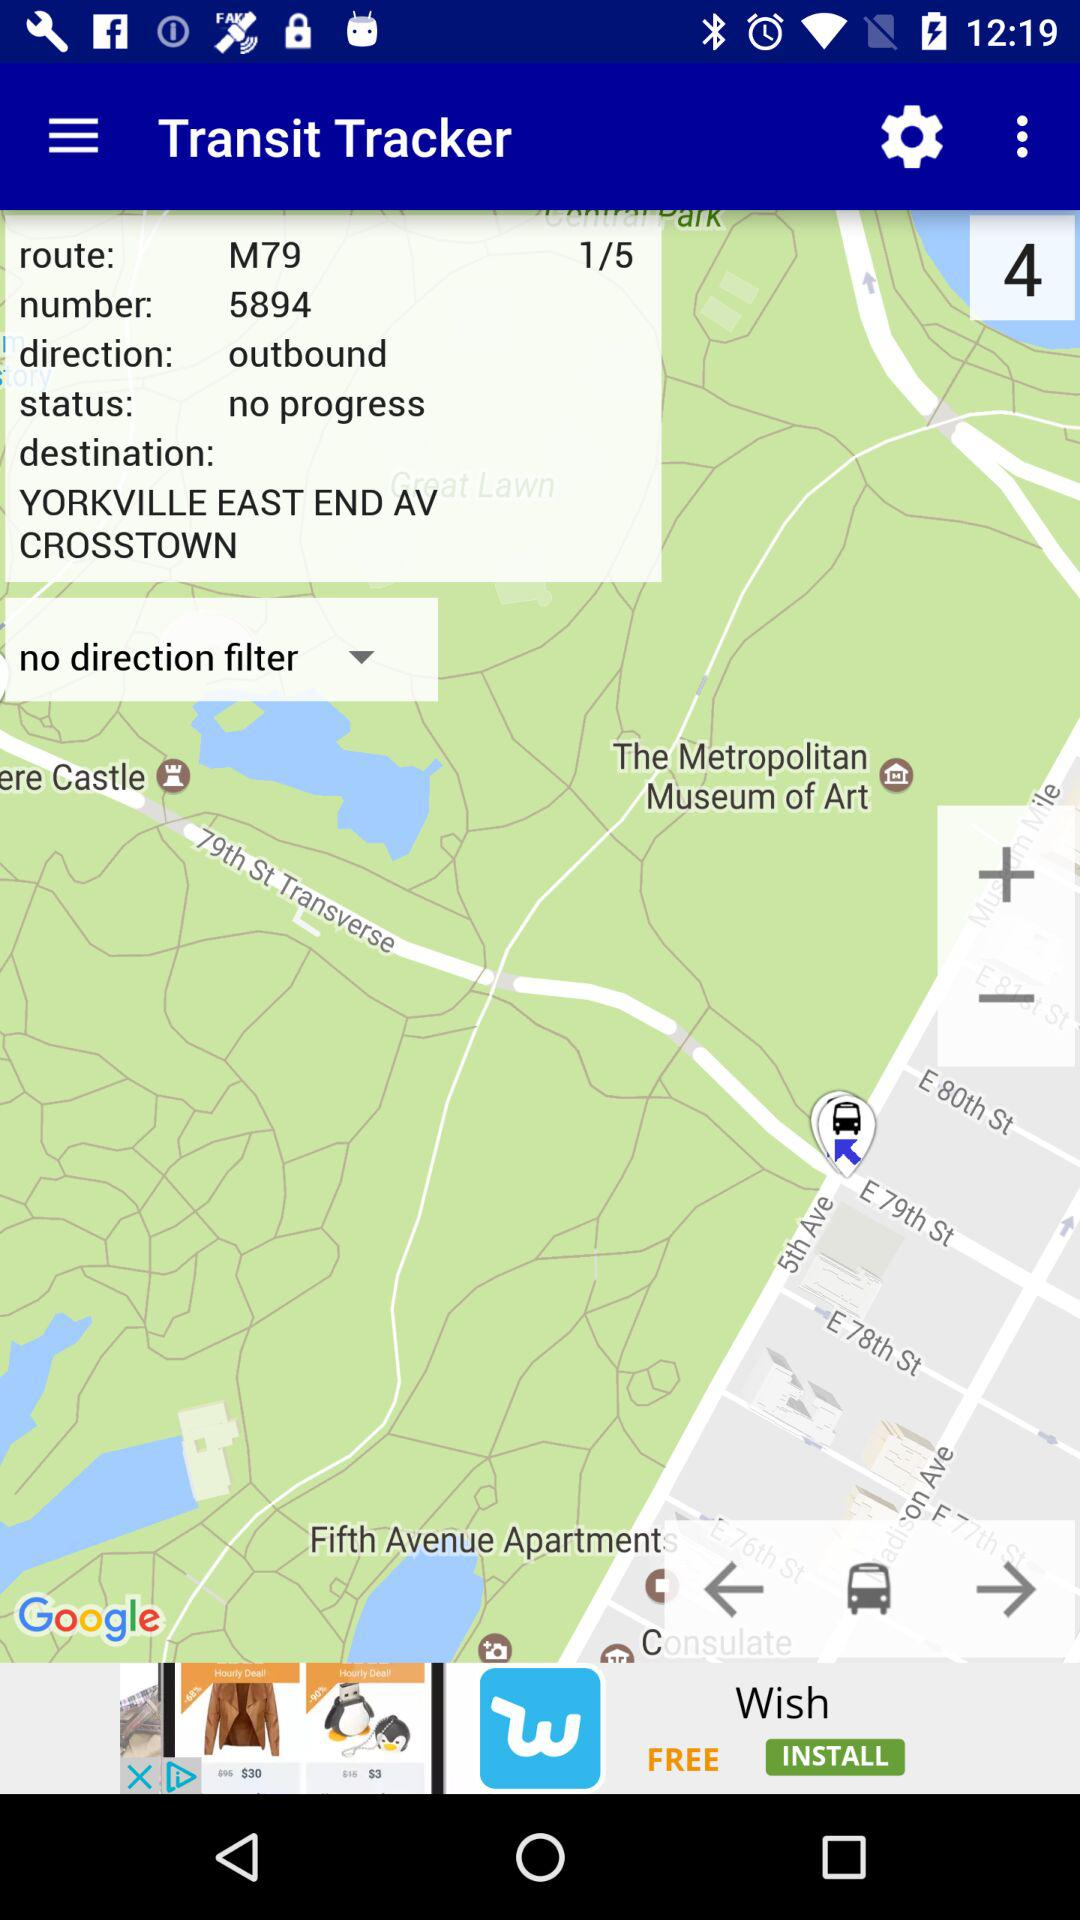What is the destination address? The destination address is Yorkville, East End Avenue, Crosstown. 